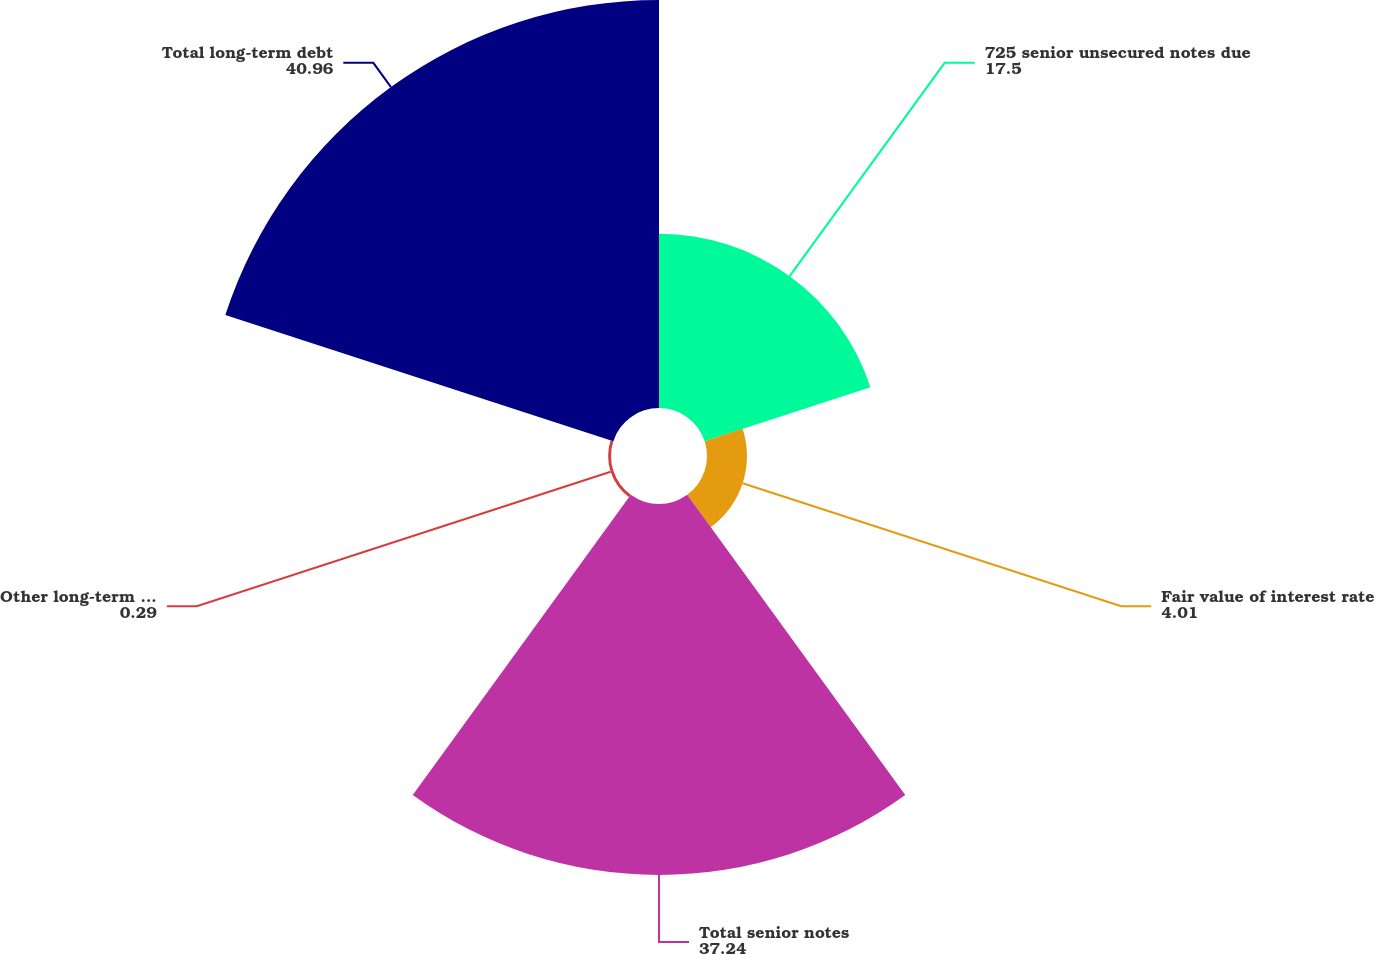Convert chart to OTSL. <chart><loc_0><loc_0><loc_500><loc_500><pie_chart><fcel>725 senior unsecured notes due<fcel>Fair value of interest rate<fcel>Total senior notes<fcel>Other long-term borrowings<fcel>Total long-term debt<nl><fcel>17.5%<fcel>4.01%<fcel>37.24%<fcel>0.29%<fcel>40.96%<nl></chart> 